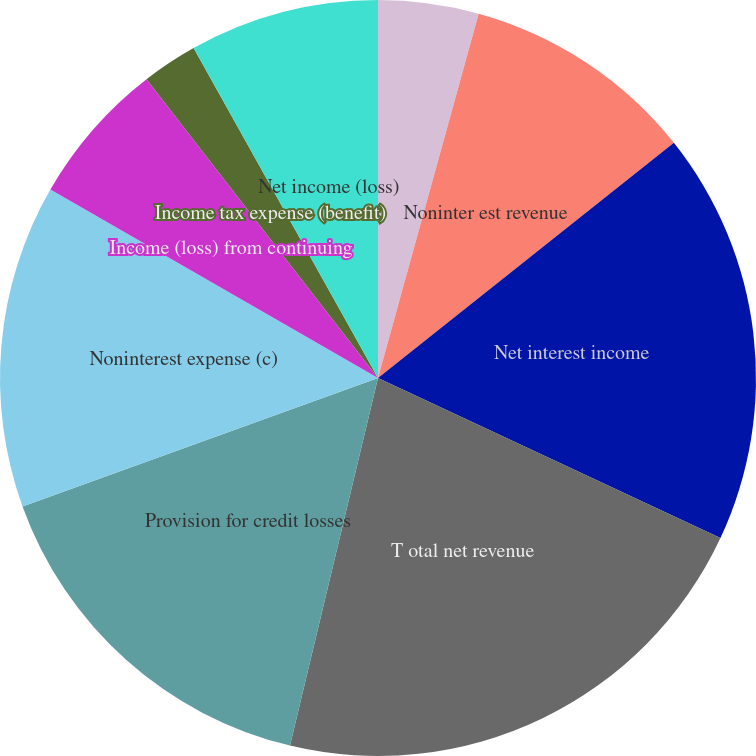<chart> <loc_0><loc_0><loc_500><loc_500><pie_chart><fcel>(in millions except ratios)<fcel>Noninter est revenue<fcel>Net interest income<fcel>T otal net revenue<fcel>Provision for credit losses<fcel>Noninterest expense (c)<fcel>Income (loss) from continuing<fcel>Income tax expense (benefit)<fcel>Net income (loss)<nl><fcel>4.29%<fcel>10.02%<fcel>17.65%<fcel>21.78%<fcel>15.74%<fcel>13.83%<fcel>6.2%<fcel>2.38%<fcel>8.11%<nl></chart> 